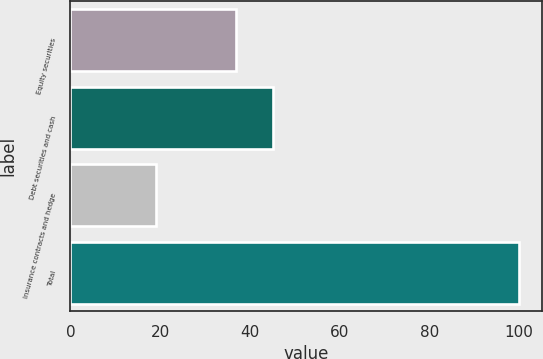Convert chart. <chart><loc_0><loc_0><loc_500><loc_500><bar_chart><fcel>Equity securities<fcel>Debt securities and cash<fcel>Insurance contracts and hedge<fcel>Total<nl><fcel>37<fcel>45.1<fcel>19<fcel>100<nl></chart> 